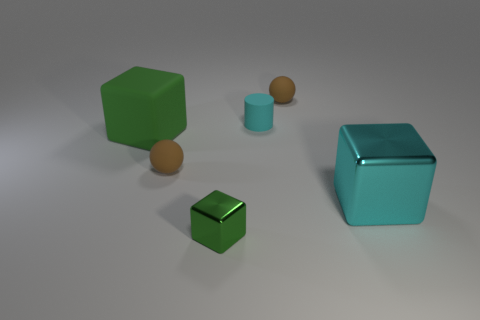What number of objects are either large purple metal cylinders or cyan metal objects?
Your answer should be very brief. 1. Do the brown rubber ball that is right of the matte cylinder and the brown rubber thing in front of the big matte block have the same size?
Your answer should be compact. Yes. How many other objects are there of the same size as the cyan metal thing?
Provide a short and direct response. 1. How many objects are brown spheres in front of the green matte cube or green objects that are on the right side of the big green matte cube?
Your response must be concise. 2. Is the material of the cyan cylinder the same as the brown object that is in front of the tiny rubber cylinder?
Ensure brevity in your answer.  Yes. What number of other things are the same shape as the tiny cyan matte thing?
Provide a succinct answer. 0. The small cyan object behind the small brown matte object on the left side of the small sphere that is on the right side of the tiny cube is made of what material?
Keep it short and to the point. Rubber. Are there an equal number of green blocks that are behind the small block and green rubber objects?
Your response must be concise. Yes. Are the cube behind the large cyan object and the small brown sphere that is behind the big rubber block made of the same material?
Your response must be concise. Yes. Is the shape of the brown matte thing that is left of the tiny green shiny thing the same as the metal object right of the tiny shiny block?
Provide a succinct answer. No. 